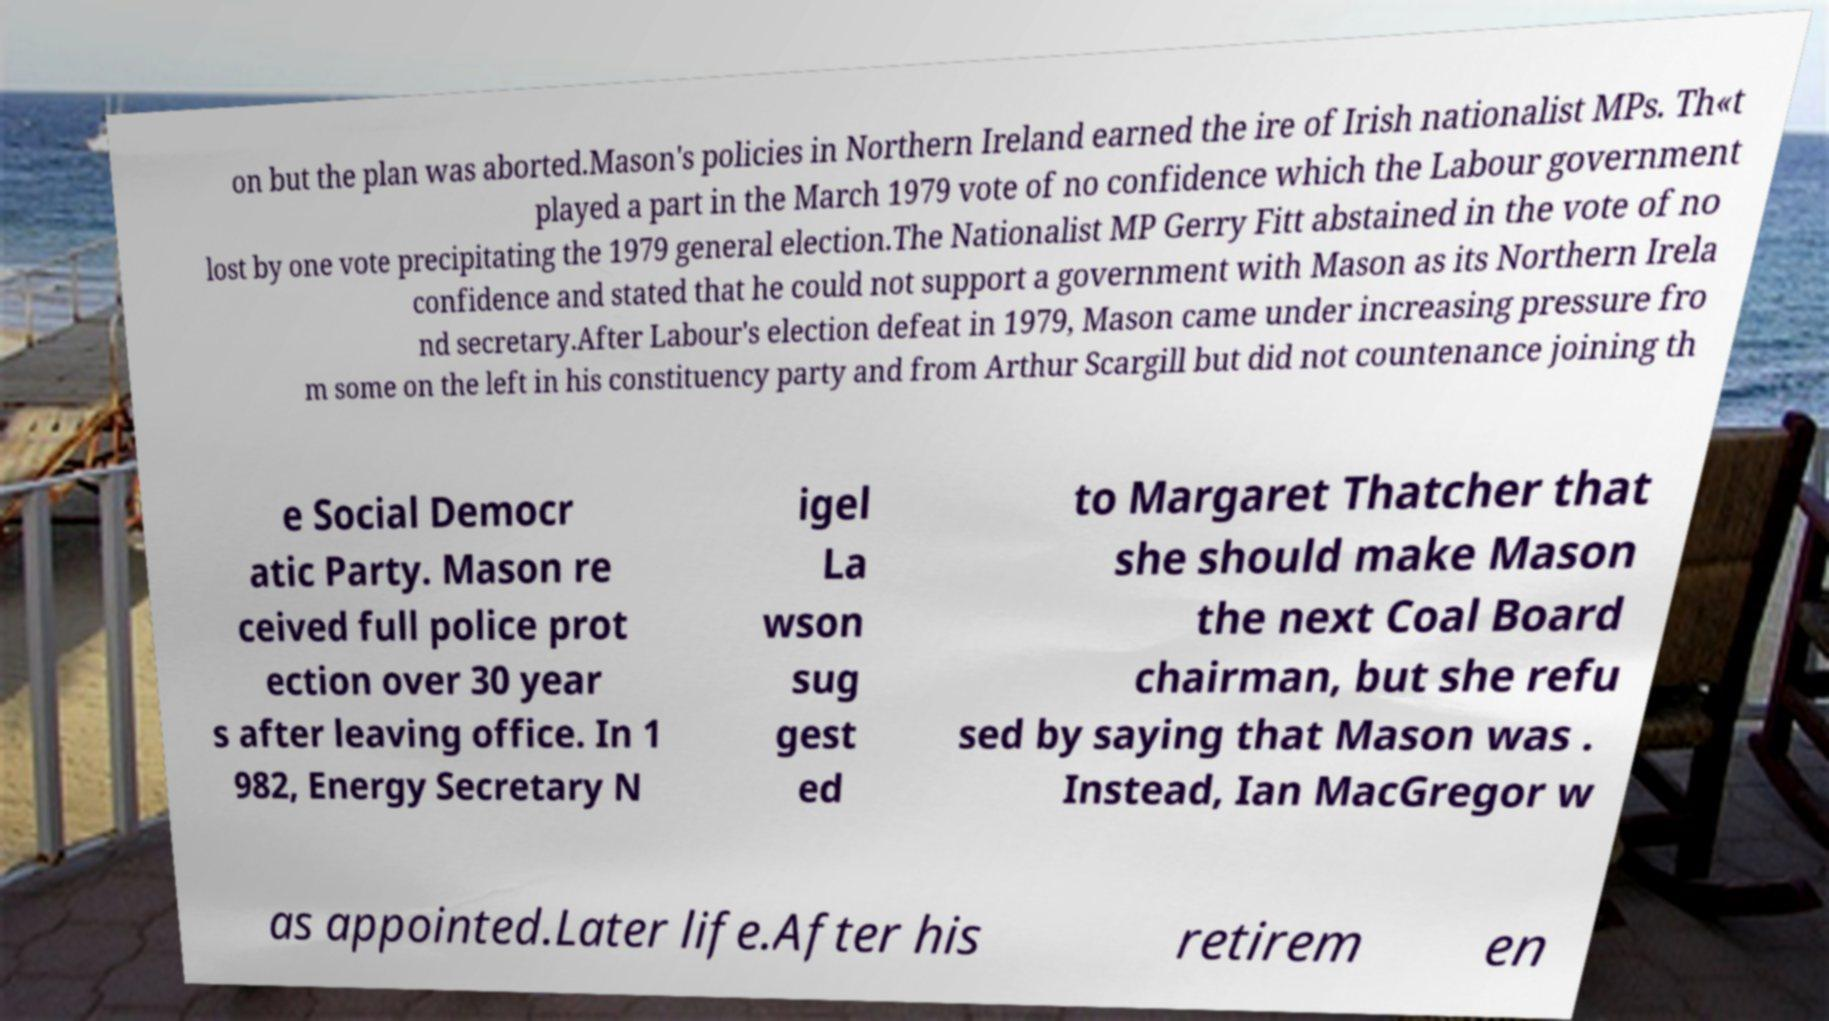Can you read and provide the text displayed in the image?This photo seems to have some interesting text. Can you extract and type it out for me? on but the plan was aborted.Mason's policies in Northern Ireland earned the ire of Irish nationalist MPs. Th«t played a part in the March 1979 vote of no confidence which the Labour government lost by one vote precipitating the 1979 general election.The Nationalist MP Gerry Fitt abstained in the vote of no confidence and stated that he could not support a government with Mason as its Northern Irela nd secretary.After Labour's election defeat in 1979, Mason came under increasing pressure fro m some on the left in his constituency party and from Arthur Scargill but did not countenance joining th e Social Democr atic Party. Mason re ceived full police prot ection over 30 year s after leaving office. In 1 982, Energy Secretary N igel La wson sug gest ed to Margaret Thatcher that she should make Mason the next Coal Board chairman, but she refu sed by saying that Mason was . Instead, Ian MacGregor w as appointed.Later life.After his retirem en 